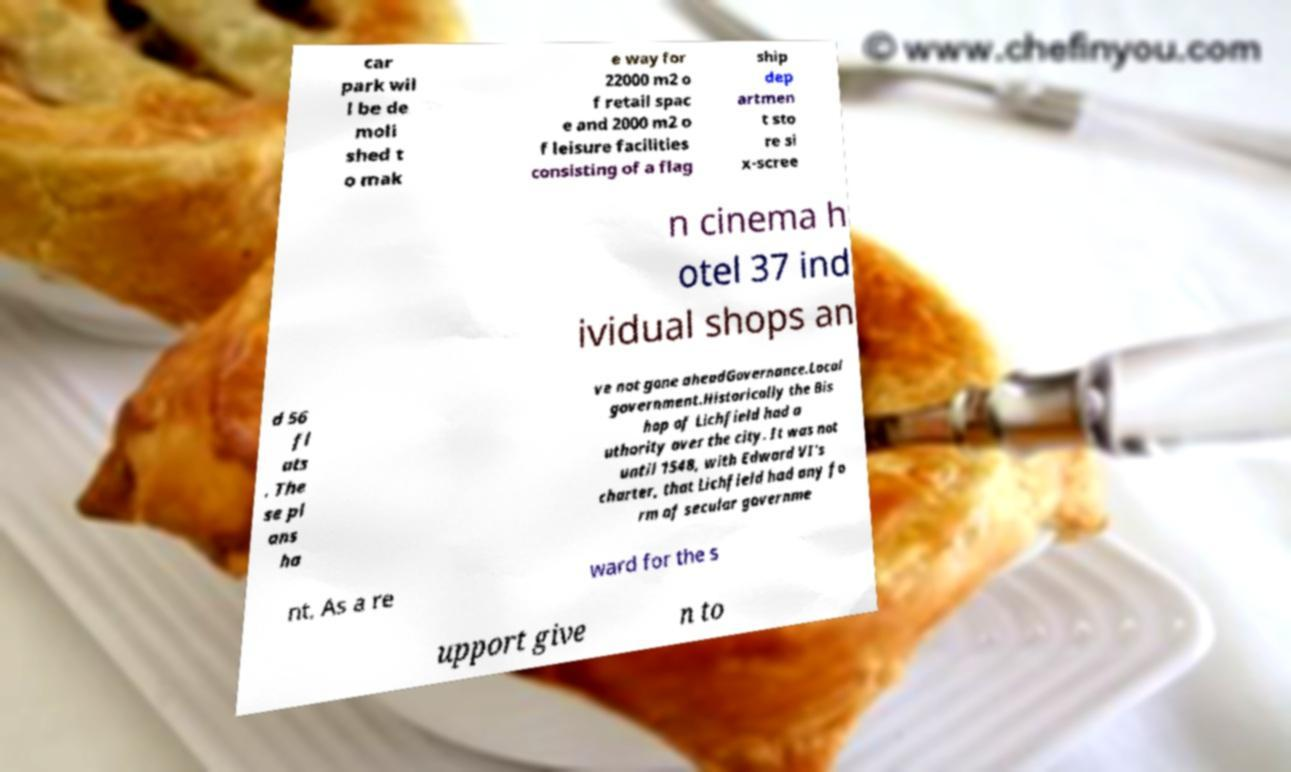For documentation purposes, I need the text within this image transcribed. Could you provide that? car park wil l be de moli shed t o mak e way for 22000 m2 o f retail spac e and 2000 m2 o f leisure facilities consisting of a flag ship dep artmen t sto re si x-scree n cinema h otel 37 ind ividual shops an d 56 fl ats . The se pl ans ha ve not gone aheadGovernance.Local government.Historically the Bis hop of Lichfield had a uthority over the city. It was not until 1548, with Edward VI's charter, that Lichfield had any fo rm of secular governme nt. As a re ward for the s upport give n to 